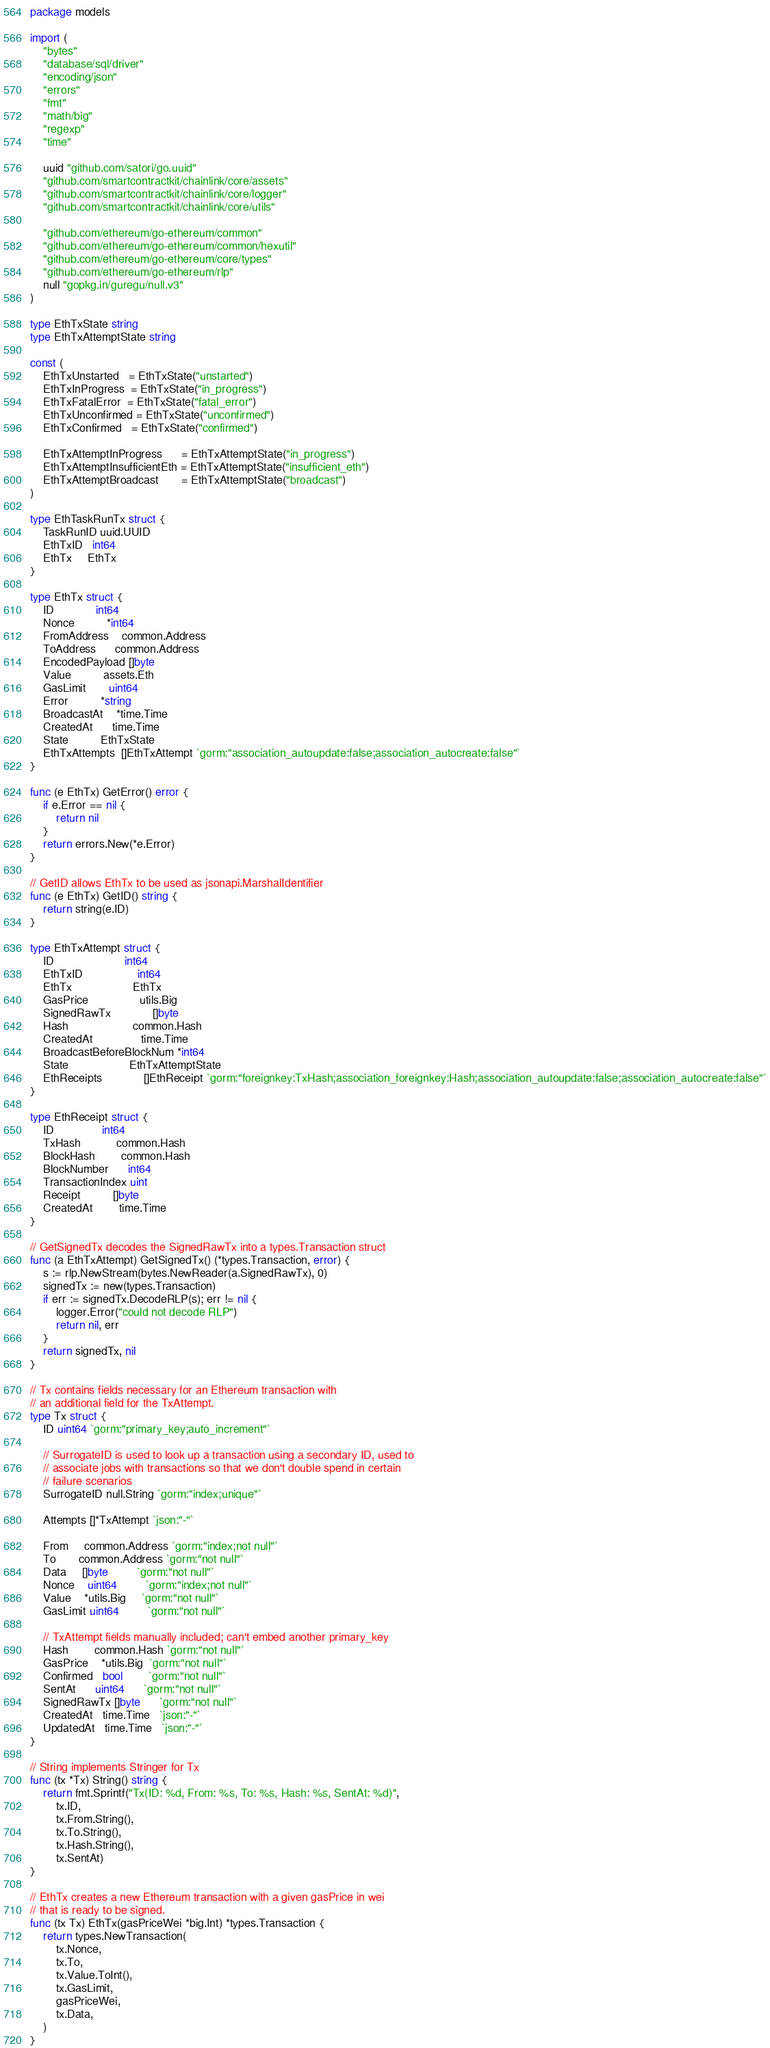Convert code to text. <code><loc_0><loc_0><loc_500><loc_500><_Go_>package models

import (
	"bytes"
	"database/sql/driver"
	"encoding/json"
	"errors"
	"fmt"
	"math/big"
	"regexp"
	"time"

	uuid "github.com/satori/go.uuid"
	"github.com/smartcontractkit/chainlink/core/assets"
	"github.com/smartcontractkit/chainlink/core/logger"
	"github.com/smartcontractkit/chainlink/core/utils"

	"github.com/ethereum/go-ethereum/common"
	"github.com/ethereum/go-ethereum/common/hexutil"
	"github.com/ethereum/go-ethereum/core/types"
	"github.com/ethereum/go-ethereum/rlp"
	null "gopkg.in/guregu/null.v3"
)

type EthTxState string
type EthTxAttemptState string

const (
	EthTxUnstarted   = EthTxState("unstarted")
	EthTxInProgress  = EthTxState("in_progress")
	EthTxFatalError  = EthTxState("fatal_error")
	EthTxUnconfirmed = EthTxState("unconfirmed")
	EthTxConfirmed   = EthTxState("confirmed")

	EthTxAttemptInProgress      = EthTxAttemptState("in_progress")
	EthTxAttemptInsufficientEth = EthTxAttemptState("insufficient_eth")
	EthTxAttemptBroadcast       = EthTxAttemptState("broadcast")
)

type EthTaskRunTx struct {
	TaskRunID uuid.UUID
	EthTxID   int64
	EthTx     EthTx
}

type EthTx struct {
	ID             int64
	Nonce          *int64
	FromAddress    common.Address
	ToAddress      common.Address
	EncodedPayload []byte
	Value          assets.Eth
	GasLimit       uint64
	Error          *string
	BroadcastAt    *time.Time
	CreatedAt      time.Time
	State          EthTxState
	EthTxAttempts  []EthTxAttempt `gorm:"association_autoupdate:false;association_autocreate:false"`
}

func (e EthTx) GetError() error {
	if e.Error == nil {
		return nil
	}
	return errors.New(*e.Error)
}

// GetID allows EthTx to be used as jsonapi.MarshalIdentifier
func (e EthTx) GetID() string {
	return string(e.ID)
}

type EthTxAttempt struct {
	ID                      int64
	EthTxID                 int64
	EthTx                   EthTx
	GasPrice                utils.Big
	SignedRawTx             []byte
	Hash                    common.Hash
	CreatedAt               time.Time
	BroadcastBeforeBlockNum *int64
	State                   EthTxAttemptState
	EthReceipts             []EthReceipt `gorm:"foreignkey:TxHash;association_foreignkey:Hash;association_autoupdate:false;association_autocreate:false"`
}

type EthReceipt struct {
	ID               int64
	TxHash           common.Hash
	BlockHash        common.Hash
	BlockNumber      int64
	TransactionIndex uint
	Receipt          []byte
	CreatedAt        time.Time
}

// GetSignedTx decodes the SignedRawTx into a types.Transaction struct
func (a EthTxAttempt) GetSignedTx() (*types.Transaction, error) {
	s := rlp.NewStream(bytes.NewReader(a.SignedRawTx), 0)
	signedTx := new(types.Transaction)
	if err := signedTx.DecodeRLP(s); err != nil {
		logger.Error("could not decode RLP")
		return nil, err
	}
	return signedTx, nil
}

// Tx contains fields necessary for an Ethereum transaction with
// an additional field for the TxAttempt.
type Tx struct {
	ID uint64 `gorm:"primary_key;auto_increment"`

	// SurrogateID is used to look up a transaction using a secondary ID, used to
	// associate jobs with transactions so that we don't double spend in certain
	// failure scenarios
	SurrogateID null.String `gorm:"index;unique"`

	Attempts []*TxAttempt `json:"-"`

	From     common.Address `gorm:"index;not null"`
	To       common.Address `gorm:"not null"`
	Data     []byte         `gorm:"not null"`
	Nonce    uint64         `gorm:"index;not null"`
	Value    *utils.Big     `gorm:"not null"`
	GasLimit uint64         `gorm:"not null"`

	// TxAttempt fields manually included; can't embed another primary_key
	Hash        common.Hash `gorm:"not null"`
	GasPrice    *utils.Big  `gorm:"not null"`
	Confirmed   bool        `gorm:"not null"`
	SentAt      uint64      `gorm:"not null"`
	SignedRawTx []byte      `gorm:"not null"`
	CreatedAt   time.Time   `json:"-"`
	UpdatedAt   time.Time   `json:"-"`
}

// String implements Stringer for Tx
func (tx *Tx) String() string {
	return fmt.Sprintf("Tx(ID: %d, From: %s, To: %s, Hash: %s, SentAt: %d)",
		tx.ID,
		tx.From.String(),
		tx.To.String(),
		tx.Hash.String(),
		tx.SentAt)
}

// EthTx creates a new Ethereum transaction with a given gasPrice in wei
// that is ready to be signed.
func (tx Tx) EthTx(gasPriceWei *big.Int) *types.Transaction {
	return types.NewTransaction(
		tx.Nonce,
		tx.To,
		tx.Value.ToInt(),
		tx.GasLimit,
		gasPriceWei,
		tx.Data,
	)
}
</code> 